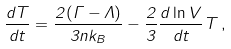Convert formula to latex. <formula><loc_0><loc_0><loc_500><loc_500>\frac { d T } { d t } = \frac { 2 ( \Gamma - \Lambda ) } { 3 n k _ { B } } - \frac { 2 } { 3 } \frac { d \ln V } { d t } T \, ,</formula> 